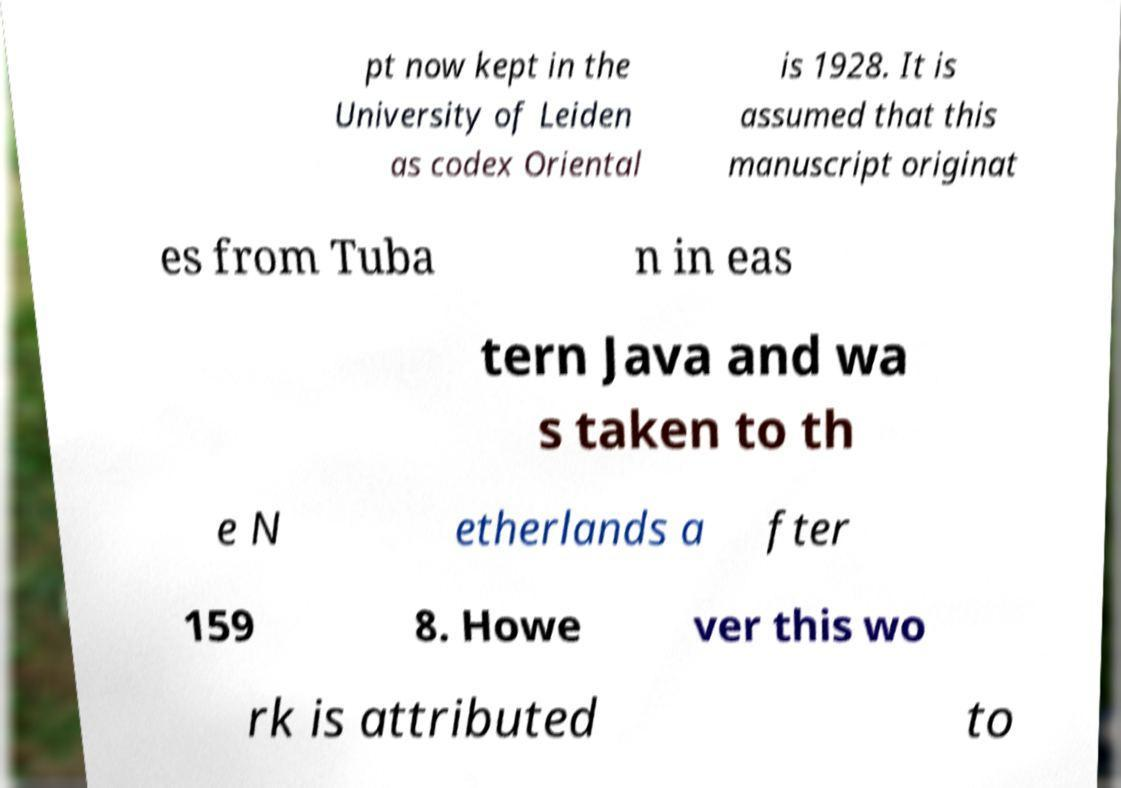Can you read and provide the text displayed in the image?This photo seems to have some interesting text. Can you extract and type it out for me? pt now kept in the University of Leiden as codex Oriental is 1928. It is assumed that this manuscript originat es from Tuba n in eas tern Java and wa s taken to th e N etherlands a fter 159 8. Howe ver this wo rk is attributed to 